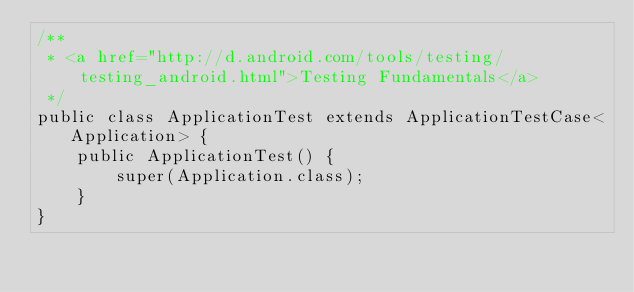Convert code to text. <code><loc_0><loc_0><loc_500><loc_500><_Java_>/**
 * <a href="http://d.android.com/tools/testing/testing_android.html">Testing Fundamentals</a>
 */
public class ApplicationTest extends ApplicationTestCase<Application> {
    public ApplicationTest() {
        super(Application.class);
    }
}</code> 